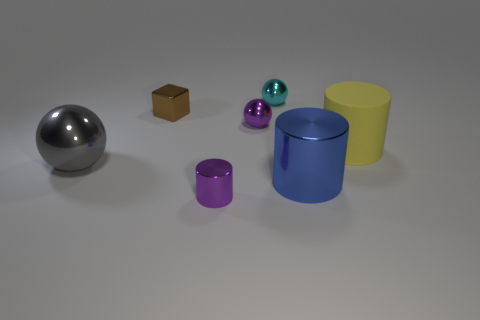What number of other objects are there of the same shape as the blue thing?
Your answer should be very brief. 2. Do the large cylinder in front of the yellow object and the tiny metallic object behind the tiny shiny cube have the same color?
Keep it short and to the point. No. Do the metallic ball to the right of the tiny purple metal sphere and the purple thing that is to the right of the tiny purple metallic cylinder have the same size?
Give a very brief answer. Yes. Is there anything else that has the same material as the large gray sphere?
Your answer should be very brief. Yes. What is the tiny purple thing behind the large thing that is left of the purple shiny thing that is in front of the gray metallic ball made of?
Keep it short and to the point. Metal. Does the big blue shiny thing have the same shape as the tiny cyan metallic object?
Provide a succinct answer. No. There is a large blue object that is the same shape as the yellow rubber thing; what is its material?
Keep it short and to the point. Metal. What number of tiny objects are the same color as the tiny cylinder?
Your response must be concise. 1. There is a brown block that is made of the same material as the large gray object; what is its size?
Give a very brief answer. Small. How many brown things are either small metallic cylinders or shiny cubes?
Provide a short and direct response. 1. 